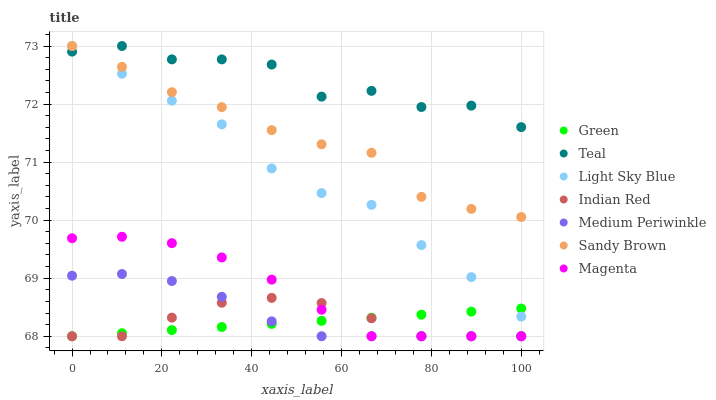Does Green have the minimum area under the curve?
Answer yes or no. Yes. Does Teal have the maximum area under the curve?
Answer yes or no. Yes. Does Medium Periwinkle have the minimum area under the curve?
Answer yes or no. No. Does Medium Periwinkle have the maximum area under the curve?
Answer yes or no. No. Is Green the smoothest?
Answer yes or no. Yes. Is Teal the roughest?
Answer yes or no. Yes. Is Medium Periwinkle the smoothest?
Answer yes or no. No. Is Medium Periwinkle the roughest?
Answer yes or no. No. Does Medium Periwinkle have the lowest value?
Answer yes or no. Yes. Does Light Sky Blue have the lowest value?
Answer yes or no. No. Does Sandy Brown have the highest value?
Answer yes or no. Yes. Does Medium Periwinkle have the highest value?
Answer yes or no. No. Is Magenta less than Light Sky Blue?
Answer yes or no. Yes. Is Sandy Brown greater than Magenta?
Answer yes or no. Yes. Does Medium Periwinkle intersect Magenta?
Answer yes or no. Yes. Is Medium Periwinkle less than Magenta?
Answer yes or no. No. Is Medium Periwinkle greater than Magenta?
Answer yes or no. No. Does Magenta intersect Light Sky Blue?
Answer yes or no. No. 